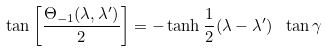<formula> <loc_0><loc_0><loc_500><loc_500>\tan \left [ \frac { \Theta _ { - 1 } ( \lambda , \lambda ^ { \prime } ) } { 2 } \right ] = - \tanh \frac { 1 } { 2 } ( \lambda - \lambda ^ { \prime } ) \ \tan \gamma</formula> 